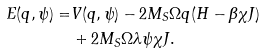<formula> <loc_0><loc_0><loc_500><loc_500>E ( q , \psi ) = & V ( q , \psi ) - 2 M _ { S } \Omega q ( H - \beta \chi J ) \\ & + 2 M _ { S } \Omega \lambda \psi \chi J .</formula> 